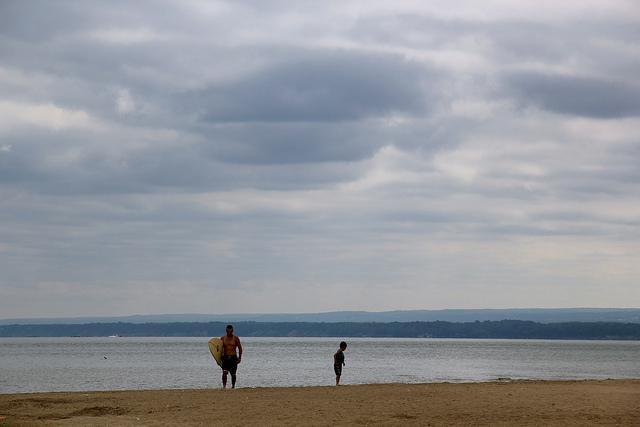How many people are on the beach?
Give a very brief answer. 2. How many people?
Give a very brief answer. 2. How many people are walking?
Give a very brief answer. 2. How many surfboards are in this photo?
Give a very brief answer. 1. 